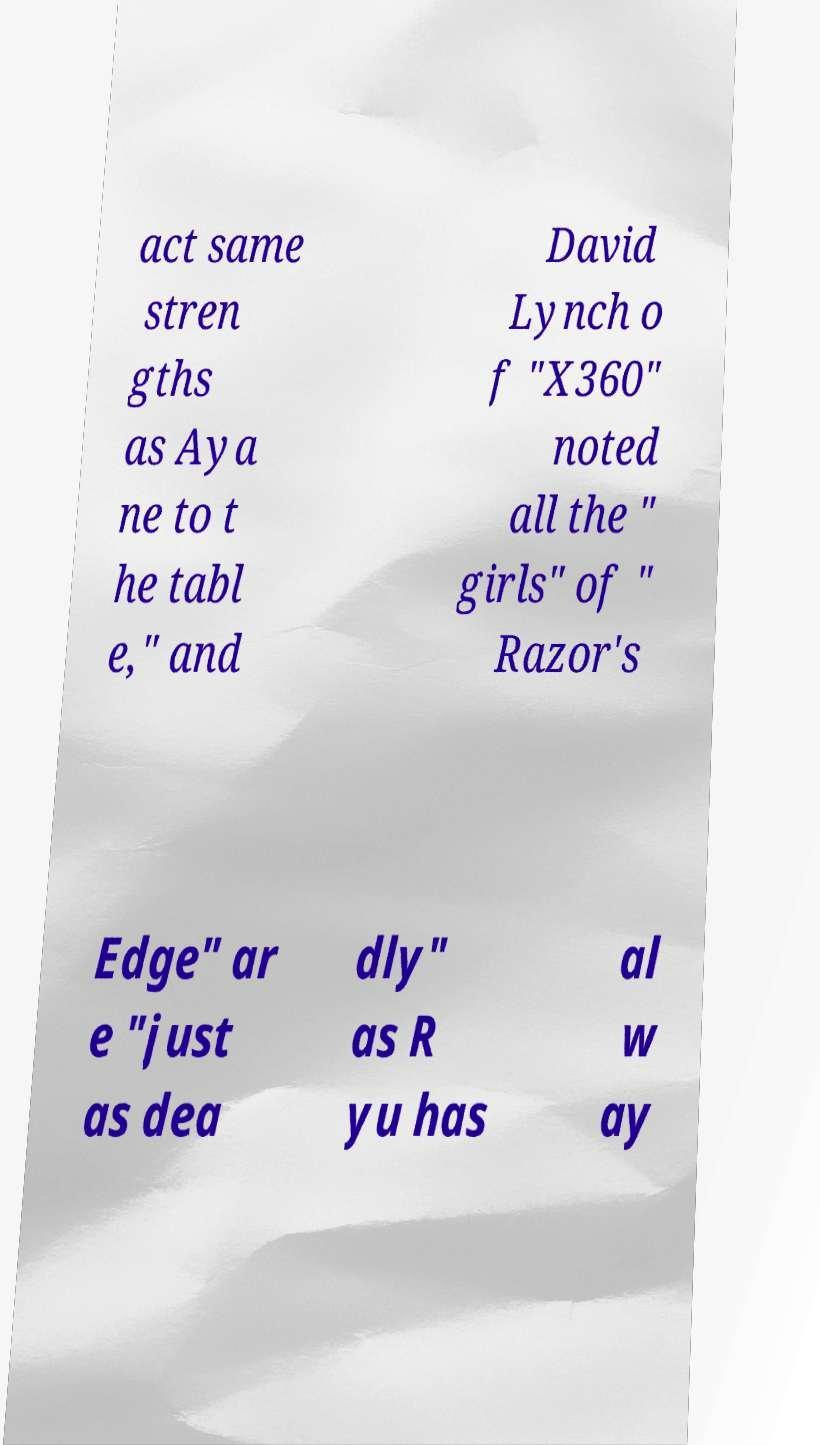For documentation purposes, I need the text within this image transcribed. Could you provide that? act same stren gths as Aya ne to t he tabl e," and David Lynch o f "X360" noted all the " girls" of " Razor's Edge" ar e "just as dea dly" as R yu has al w ay 